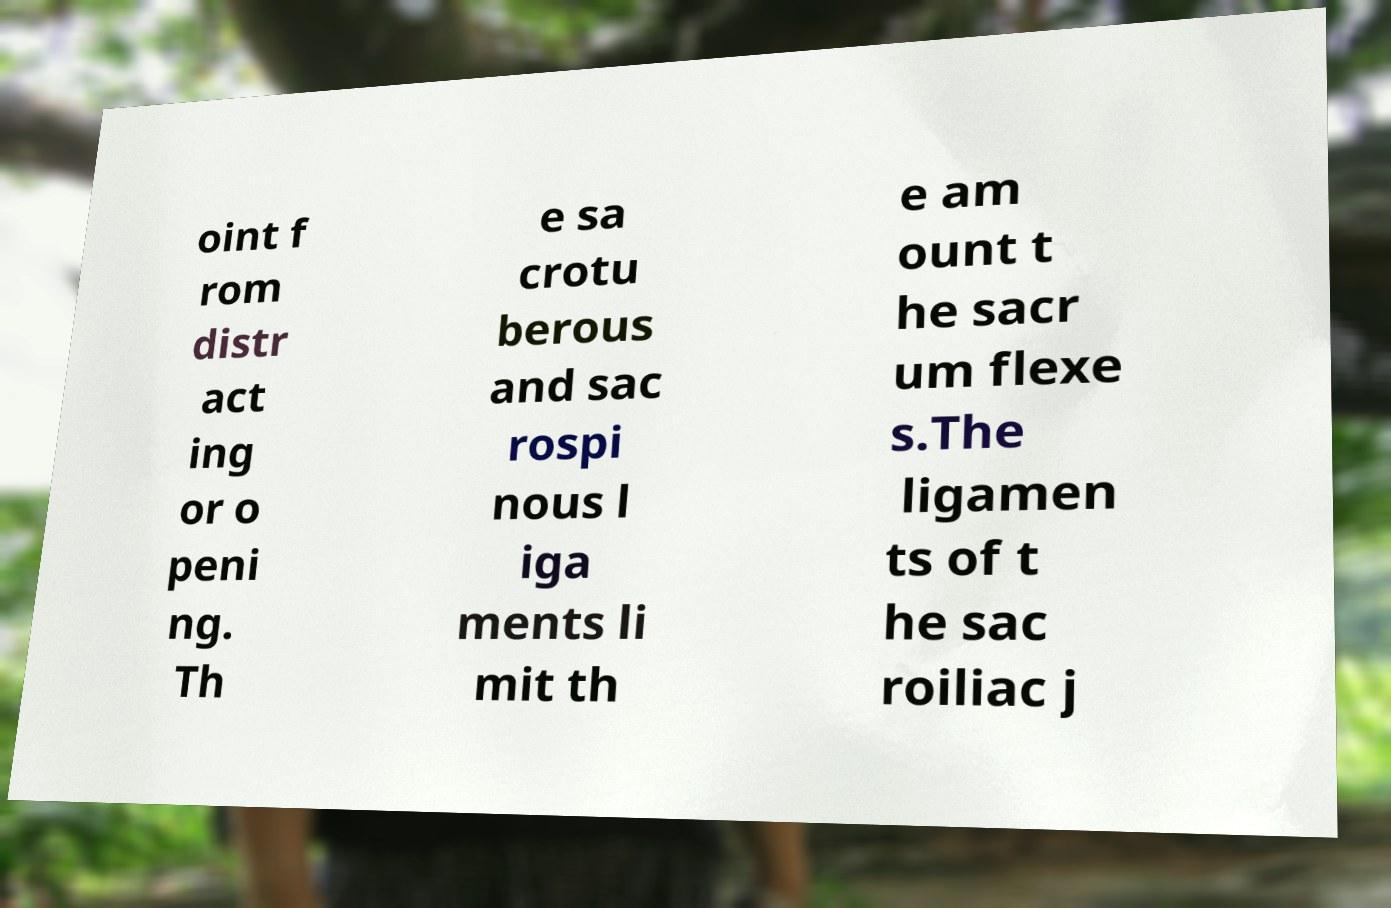Can you read and provide the text displayed in the image?This photo seems to have some interesting text. Can you extract and type it out for me? oint f rom distr act ing or o peni ng. Th e sa crotu berous and sac rospi nous l iga ments li mit th e am ount t he sacr um flexe s.The ligamen ts of t he sac roiliac j 